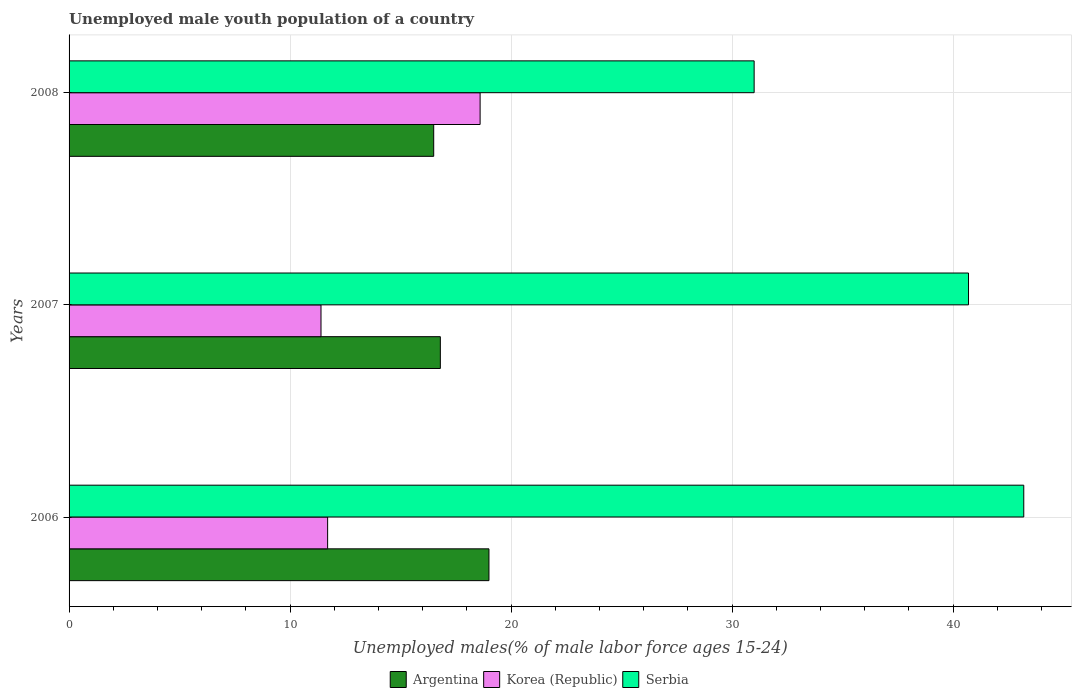What is the label of the 2nd group of bars from the top?
Provide a short and direct response. 2007. What is the percentage of unemployed male youth population in Korea (Republic) in 2008?
Your answer should be compact. 18.6. Across all years, what is the maximum percentage of unemployed male youth population in Argentina?
Your answer should be very brief. 19. Across all years, what is the minimum percentage of unemployed male youth population in Korea (Republic)?
Offer a terse response. 11.4. What is the total percentage of unemployed male youth population in Korea (Republic) in the graph?
Your answer should be compact. 41.7. What is the difference between the percentage of unemployed male youth population in Korea (Republic) in 2006 and the percentage of unemployed male youth population in Argentina in 2007?
Your answer should be compact. -5.1. What is the average percentage of unemployed male youth population in Korea (Republic) per year?
Ensure brevity in your answer.  13.9. In the year 2006, what is the difference between the percentage of unemployed male youth population in Serbia and percentage of unemployed male youth population in Argentina?
Provide a short and direct response. 24.2. In how many years, is the percentage of unemployed male youth population in Korea (Republic) greater than 22 %?
Make the answer very short. 0. What is the ratio of the percentage of unemployed male youth population in Argentina in 2006 to that in 2008?
Your response must be concise. 1.15. Is the percentage of unemployed male youth population in Serbia in 2006 less than that in 2008?
Provide a succinct answer. No. What is the difference between the highest and the second highest percentage of unemployed male youth population in Serbia?
Your response must be concise. 2.5. What is the difference between the highest and the lowest percentage of unemployed male youth population in Korea (Republic)?
Your answer should be compact. 7.2. Is the sum of the percentage of unemployed male youth population in Korea (Republic) in 2007 and 2008 greater than the maximum percentage of unemployed male youth population in Argentina across all years?
Give a very brief answer. Yes. What does the 3rd bar from the top in 2008 represents?
Offer a terse response. Argentina. Is it the case that in every year, the sum of the percentage of unemployed male youth population in Korea (Republic) and percentage of unemployed male youth population in Argentina is greater than the percentage of unemployed male youth population in Serbia?
Give a very brief answer. No. How many bars are there?
Make the answer very short. 9. How many years are there in the graph?
Your answer should be compact. 3. What is the difference between two consecutive major ticks on the X-axis?
Ensure brevity in your answer.  10. Does the graph contain any zero values?
Your answer should be very brief. No. Does the graph contain grids?
Your response must be concise. Yes. What is the title of the graph?
Provide a short and direct response. Unemployed male youth population of a country. Does "Channel Islands" appear as one of the legend labels in the graph?
Provide a succinct answer. No. What is the label or title of the X-axis?
Your answer should be compact. Unemployed males(% of male labor force ages 15-24). What is the label or title of the Y-axis?
Make the answer very short. Years. What is the Unemployed males(% of male labor force ages 15-24) of Argentina in 2006?
Offer a very short reply. 19. What is the Unemployed males(% of male labor force ages 15-24) in Korea (Republic) in 2006?
Offer a very short reply. 11.7. What is the Unemployed males(% of male labor force ages 15-24) of Serbia in 2006?
Keep it short and to the point. 43.2. What is the Unemployed males(% of male labor force ages 15-24) of Argentina in 2007?
Ensure brevity in your answer.  16.8. What is the Unemployed males(% of male labor force ages 15-24) in Korea (Republic) in 2007?
Give a very brief answer. 11.4. What is the Unemployed males(% of male labor force ages 15-24) in Serbia in 2007?
Your response must be concise. 40.7. What is the Unemployed males(% of male labor force ages 15-24) of Korea (Republic) in 2008?
Provide a succinct answer. 18.6. What is the Unemployed males(% of male labor force ages 15-24) in Serbia in 2008?
Provide a succinct answer. 31. Across all years, what is the maximum Unemployed males(% of male labor force ages 15-24) of Korea (Republic)?
Offer a terse response. 18.6. Across all years, what is the maximum Unemployed males(% of male labor force ages 15-24) in Serbia?
Provide a succinct answer. 43.2. Across all years, what is the minimum Unemployed males(% of male labor force ages 15-24) in Argentina?
Make the answer very short. 16.5. Across all years, what is the minimum Unemployed males(% of male labor force ages 15-24) of Korea (Republic)?
Ensure brevity in your answer.  11.4. Across all years, what is the minimum Unemployed males(% of male labor force ages 15-24) of Serbia?
Give a very brief answer. 31. What is the total Unemployed males(% of male labor force ages 15-24) of Argentina in the graph?
Give a very brief answer. 52.3. What is the total Unemployed males(% of male labor force ages 15-24) of Korea (Republic) in the graph?
Provide a short and direct response. 41.7. What is the total Unemployed males(% of male labor force ages 15-24) in Serbia in the graph?
Keep it short and to the point. 114.9. What is the difference between the Unemployed males(% of male labor force ages 15-24) of Korea (Republic) in 2006 and that in 2007?
Give a very brief answer. 0.3. What is the difference between the Unemployed males(% of male labor force ages 15-24) of Argentina in 2006 and that in 2008?
Provide a short and direct response. 2.5. What is the difference between the Unemployed males(% of male labor force ages 15-24) of Serbia in 2006 and that in 2008?
Provide a short and direct response. 12.2. What is the difference between the Unemployed males(% of male labor force ages 15-24) in Korea (Republic) in 2007 and that in 2008?
Offer a terse response. -7.2. What is the difference between the Unemployed males(% of male labor force ages 15-24) of Serbia in 2007 and that in 2008?
Keep it short and to the point. 9.7. What is the difference between the Unemployed males(% of male labor force ages 15-24) of Argentina in 2006 and the Unemployed males(% of male labor force ages 15-24) of Serbia in 2007?
Provide a succinct answer. -21.7. What is the difference between the Unemployed males(% of male labor force ages 15-24) in Korea (Republic) in 2006 and the Unemployed males(% of male labor force ages 15-24) in Serbia in 2007?
Make the answer very short. -29. What is the difference between the Unemployed males(% of male labor force ages 15-24) in Argentina in 2006 and the Unemployed males(% of male labor force ages 15-24) in Serbia in 2008?
Give a very brief answer. -12. What is the difference between the Unemployed males(% of male labor force ages 15-24) of Korea (Republic) in 2006 and the Unemployed males(% of male labor force ages 15-24) of Serbia in 2008?
Your answer should be very brief. -19.3. What is the difference between the Unemployed males(% of male labor force ages 15-24) of Argentina in 2007 and the Unemployed males(% of male labor force ages 15-24) of Serbia in 2008?
Offer a terse response. -14.2. What is the difference between the Unemployed males(% of male labor force ages 15-24) in Korea (Republic) in 2007 and the Unemployed males(% of male labor force ages 15-24) in Serbia in 2008?
Your response must be concise. -19.6. What is the average Unemployed males(% of male labor force ages 15-24) of Argentina per year?
Your answer should be compact. 17.43. What is the average Unemployed males(% of male labor force ages 15-24) of Korea (Republic) per year?
Keep it short and to the point. 13.9. What is the average Unemployed males(% of male labor force ages 15-24) of Serbia per year?
Your answer should be compact. 38.3. In the year 2006, what is the difference between the Unemployed males(% of male labor force ages 15-24) of Argentina and Unemployed males(% of male labor force ages 15-24) of Serbia?
Offer a terse response. -24.2. In the year 2006, what is the difference between the Unemployed males(% of male labor force ages 15-24) in Korea (Republic) and Unemployed males(% of male labor force ages 15-24) in Serbia?
Provide a succinct answer. -31.5. In the year 2007, what is the difference between the Unemployed males(% of male labor force ages 15-24) in Argentina and Unemployed males(% of male labor force ages 15-24) in Serbia?
Provide a succinct answer. -23.9. In the year 2007, what is the difference between the Unemployed males(% of male labor force ages 15-24) in Korea (Republic) and Unemployed males(% of male labor force ages 15-24) in Serbia?
Provide a short and direct response. -29.3. In the year 2008, what is the difference between the Unemployed males(% of male labor force ages 15-24) of Argentina and Unemployed males(% of male labor force ages 15-24) of Korea (Republic)?
Your answer should be compact. -2.1. In the year 2008, what is the difference between the Unemployed males(% of male labor force ages 15-24) in Korea (Republic) and Unemployed males(% of male labor force ages 15-24) in Serbia?
Provide a succinct answer. -12.4. What is the ratio of the Unemployed males(% of male labor force ages 15-24) in Argentina in 2006 to that in 2007?
Your answer should be compact. 1.13. What is the ratio of the Unemployed males(% of male labor force ages 15-24) of Korea (Republic) in 2006 to that in 2007?
Make the answer very short. 1.03. What is the ratio of the Unemployed males(% of male labor force ages 15-24) in Serbia in 2006 to that in 2007?
Make the answer very short. 1.06. What is the ratio of the Unemployed males(% of male labor force ages 15-24) in Argentina in 2006 to that in 2008?
Your answer should be compact. 1.15. What is the ratio of the Unemployed males(% of male labor force ages 15-24) in Korea (Republic) in 2006 to that in 2008?
Ensure brevity in your answer.  0.63. What is the ratio of the Unemployed males(% of male labor force ages 15-24) in Serbia in 2006 to that in 2008?
Provide a short and direct response. 1.39. What is the ratio of the Unemployed males(% of male labor force ages 15-24) in Argentina in 2007 to that in 2008?
Offer a very short reply. 1.02. What is the ratio of the Unemployed males(% of male labor force ages 15-24) of Korea (Republic) in 2007 to that in 2008?
Keep it short and to the point. 0.61. What is the ratio of the Unemployed males(% of male labor force ages 15-24) in Serbia in 2007 to that in 2008?
Your answer should be very brief. 1.31. What is the difference between the highest and the second highest Unemployed males(% of male labor force ages 15-24) of Korea (Republic)?
Offer a terse response. 6.9. What is the difference between the highest and the second highest Unemployed males(% of male labor force ages 15-24) in Serbia?
Provide a short and direct response. 2.5. What is the difference between the highest and the lowest Unemployed males(% of male labor force ages 15-24) in Argentina?
Your answer should be very brief. 2.5. What is the difference between the highest and the lowest Unemployed males(% of male labor force ages 15-24) of Korea (Republic)?
Ensure brevity in your answer.  7.2. What is the difference between the highest and the lowest Unemployed males(% of male labor force ages 15-24) in Serbia?
Make the answer very short. 12.2. 